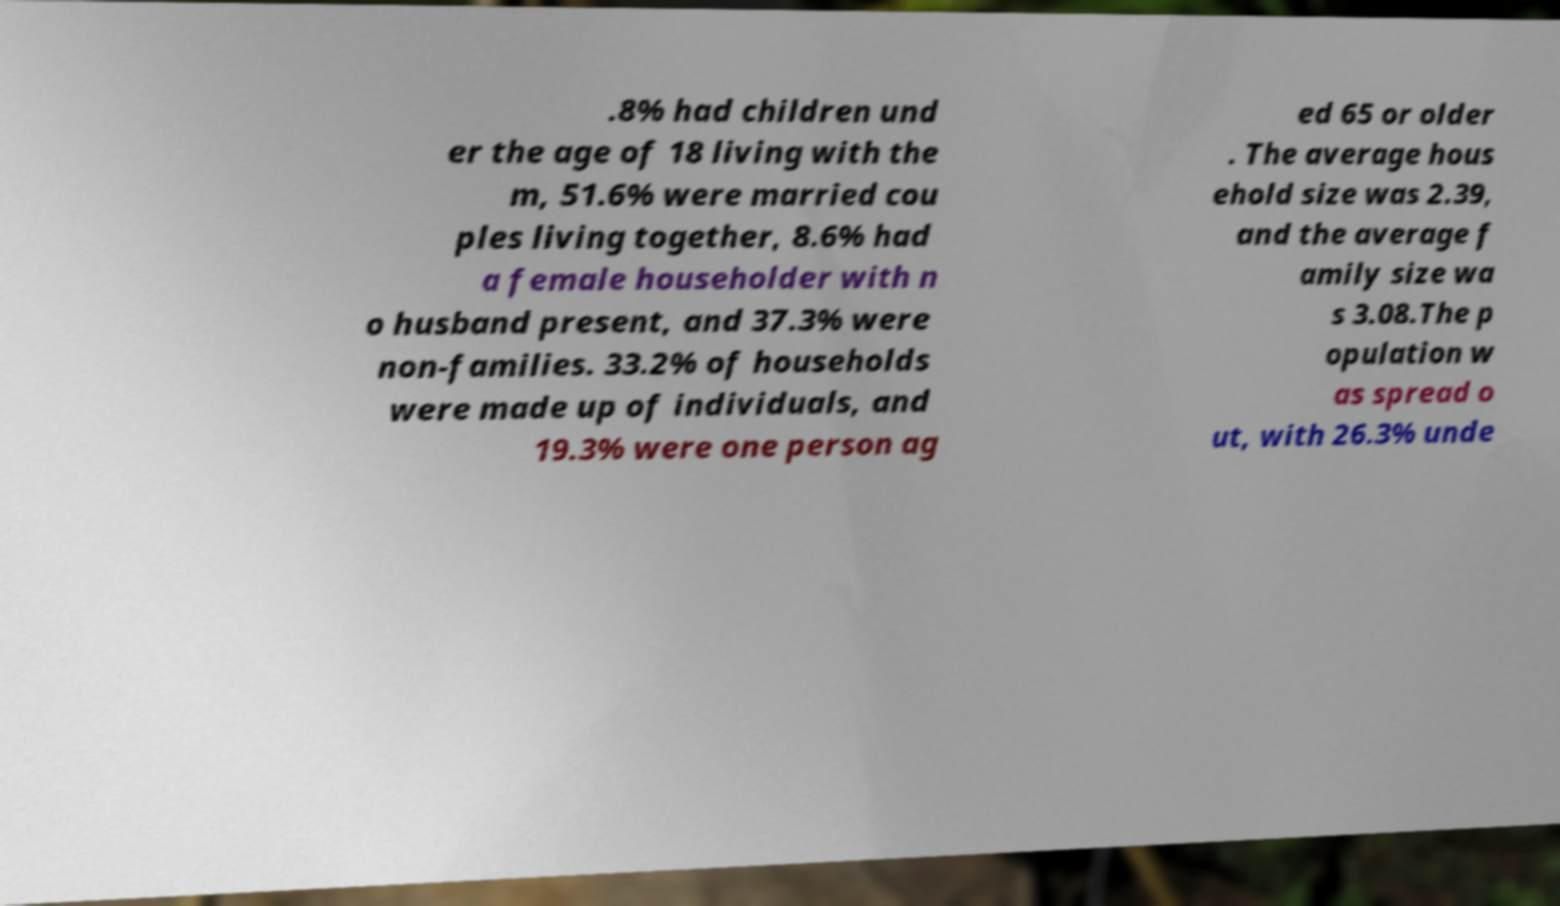Can you accurately transcribe the text from the provided image for me? .8% had children und er the age of 18 living with the m, 51.6% were married cou ples living together, 8.6% had a female householder with n o husband present, and 37.3% were non-families. 33.2% of households were made up of individuals, and 19.3% were one person ag ed 65 or older . The average hous ehold size was 2.39, and the average f amily size wa s 3.08.The p opulation w as spread o ut, with 26.3% unde 